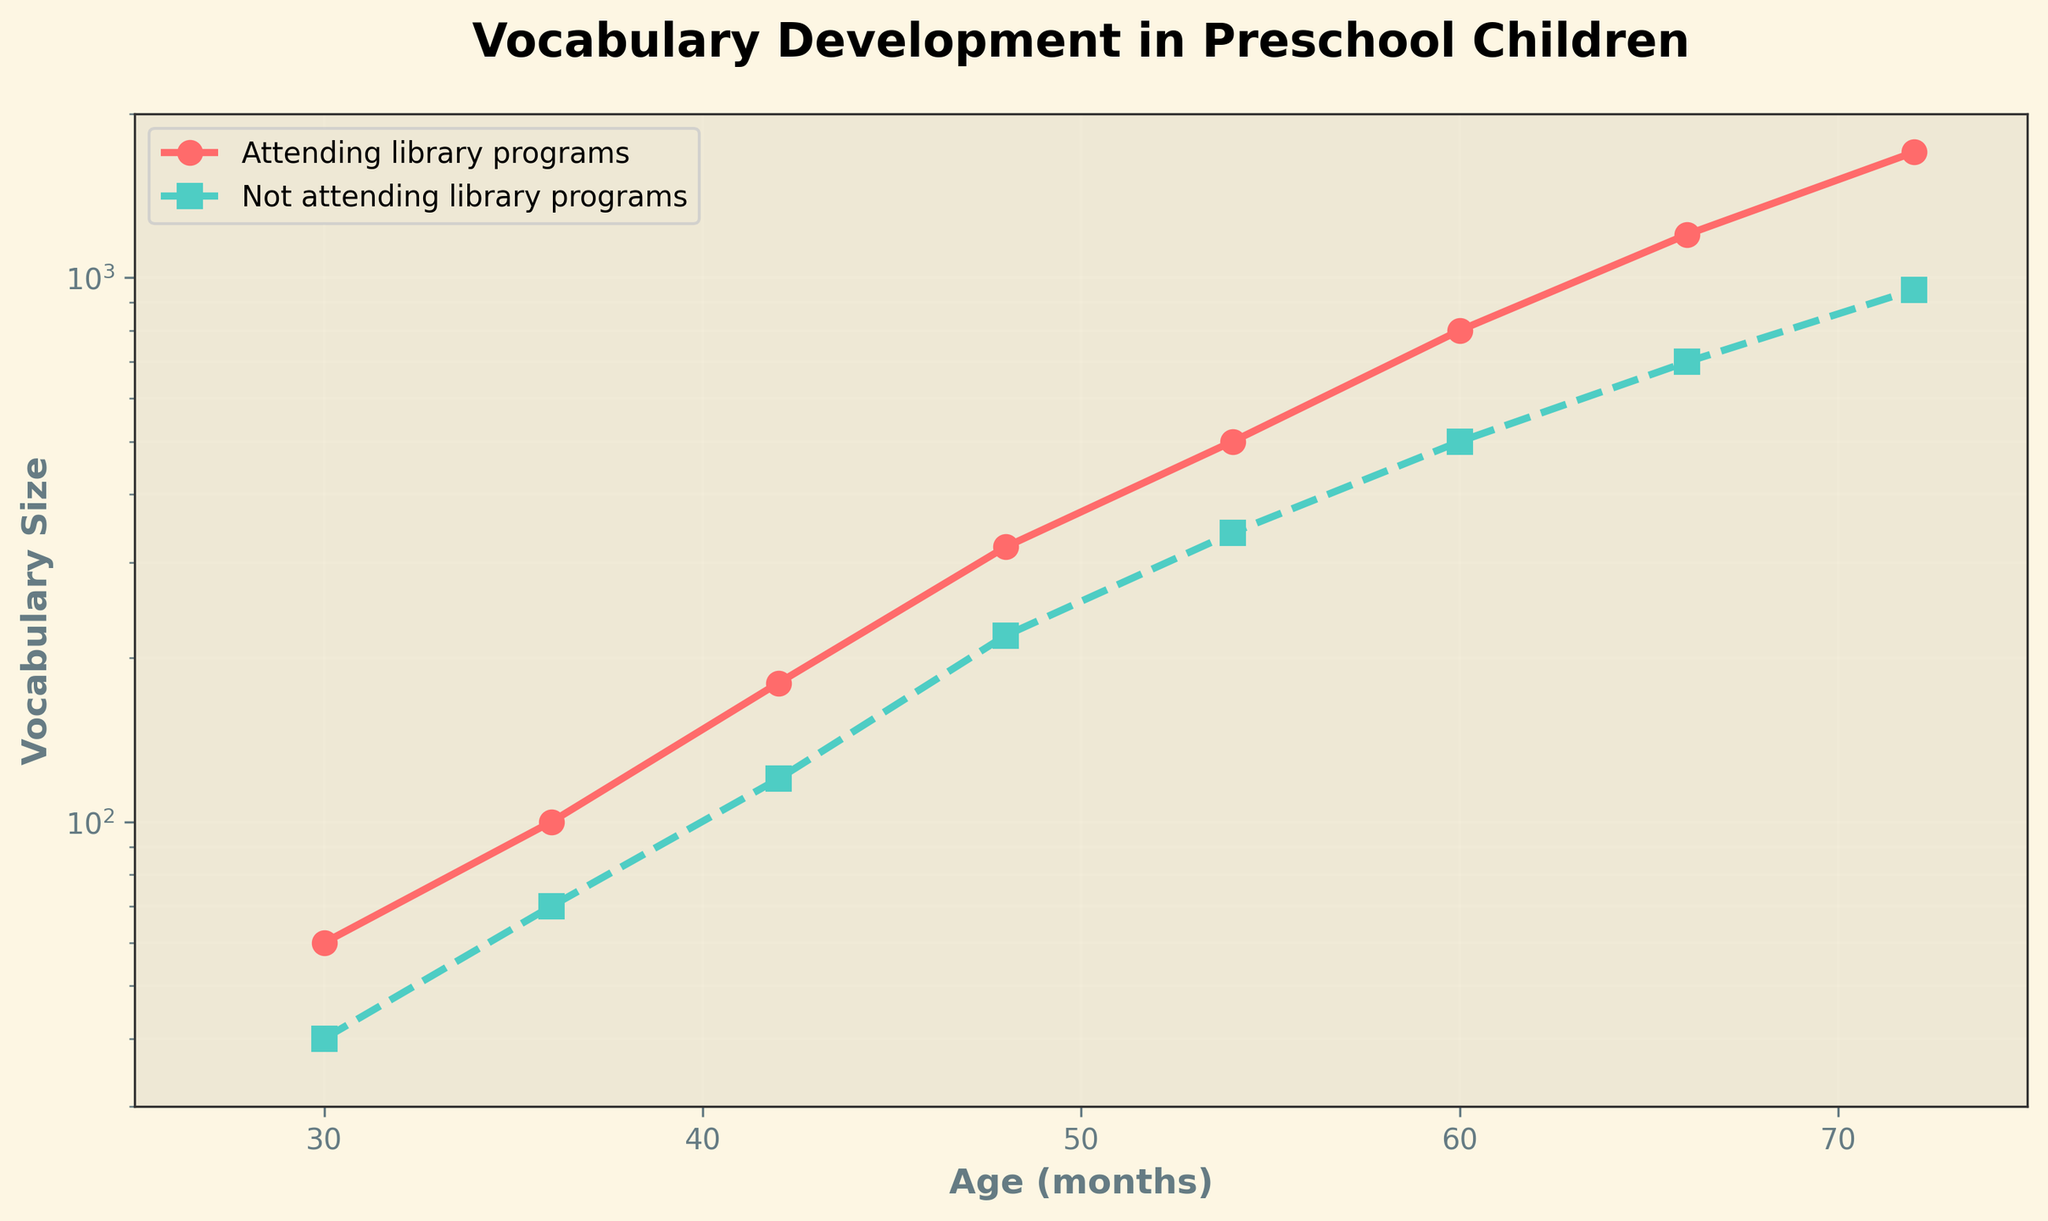What's the title of the plot? The title is written at the top of the figure.
Answer: Vocabulary Development in Preschool Children How many age groups are represented in the plot? By counting the number of data points or checking the x-axis ticks, we see there are 8 age groups.
Answer: 8 Which group shows a higher vocabulary size at age 60 months? We compare the y-values at age 60 months for both groups. The line representing children attending library programs is higher.
Answer: Children attending library programs At what age do children attending library programs start showing a noticeably larger vocabulary size than those who don't? Look at the point where the red line (attending library programs) significantly pulls away from the teal line (not attending library programs). This starts around 48 months.
Answer: 48 months What is the range of vocabulary size for children not attending library programs? The range can be determined by the smallest and largest y-values on the green line for children not attending library programs, which are 40 to 950.
Answer: 40 to 950 By how much does the vocabulary size of children attending library programs increase from age 30 months to 72 months? Find the y-values for age 30 and 72 months on the red line and calculate the difference: 1700 - 60 = 1640.
Answer: 1640 What is the shape of the relationship between children's age and vocabulary size? The plot shows a roughly exponential increase, which is confirmed by the logarithmic y-scale and the upward bending lines.
Answer: Exponential increase What is the vocabulary size for children attending library programs at age 54 months? Read off the y-value of the red line at age 54 months.
Answer: 500 Do both groups follow the same trend, and do they have similar rates of vocabulary growth over time? Both lines have a similar exponential upward trend but children attending library programs have a steeper rate of growth.
Answer: Same trend, different rates At age 66 months, how much larger is the vocabulary size for children attending library programs compared to those who don't? Find the y-values for both groups at age 66 months and subtract: 1200 - 700 = 500.
Answer: 500 